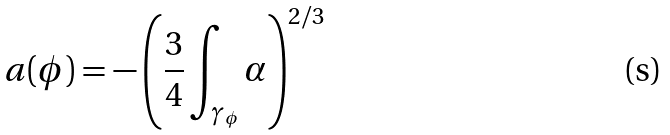Convert formula to latex. <formula><loc_0><loc_0><loc_500><loc_500>a ( \phi ) = - \left ( \frac { 3 } { 4 } \int _ { \gamma _ { \phi } } \alpha \right ) ^ { 2 / 3 }</formula> 